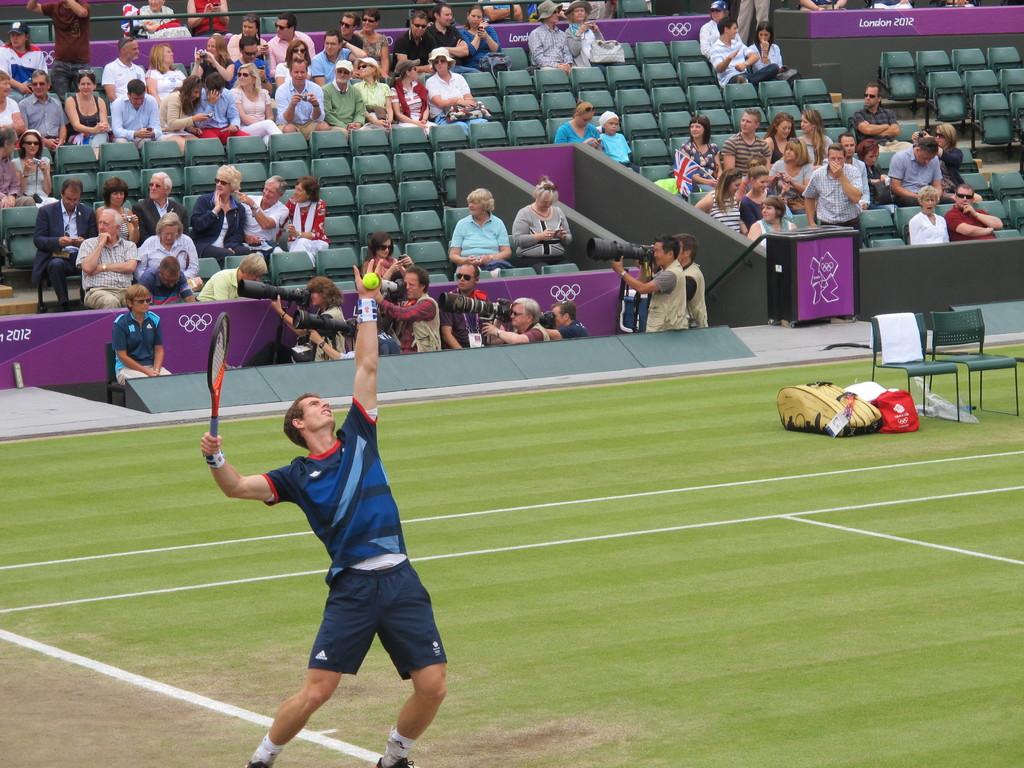What year is this?
Your answer should be compact. 2012. 